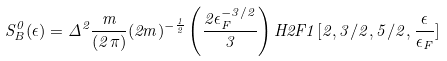Convert formula to latex. <formula><loc_0><loc_0><loc_500><loc_500>S ^ { 0 } _ { B } ( \epsilon ) = \Delta ^ { 2 } \frac { m } { ( 2 \pi ) } ( 2 m ) ^ { - \frac { 1 } { 2 } } \left ( \frac { 2 \epsilon _ { F } ^ { - 3 / 2 } } { 3 } \right ) H 2 F 1 [ 2 , 3 / 2 , 5 / 2 , \frac { \epsilon } { \epsilon _ { F } } ]</formula> 